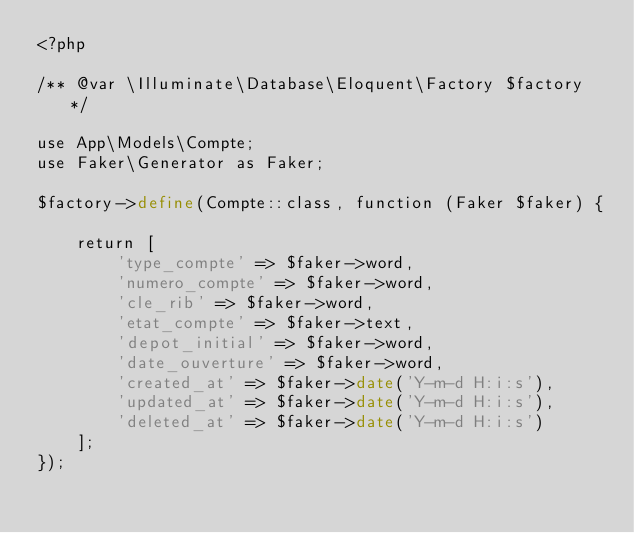Convert code to text. <code><loc_0><loc_0><loc_500><loc_500><_PHP_><?php

/** @var \Illuminate\Database\Eloquent\Factory $factory */

use App\Models\Compte;
use Faker\Generator as Faker;

$factory->define(Compte::class, function (Faker $faker) {

    return [
        'type_compte' => $faker->word,
        'numero_compte' => $faker->word,
        'cle_rib' => $faker->word,
        'etat_compte' => $faker->text,
        'depot_initial' => $faker->word,
        'date_ouverture' => $faker->word,
        'created_at' => $faker->date('Y-m-d H:i:s'),
        'updated_at' => $faker->date('Y-m-d H:i:s'),
        'deleted_at' => $faker->date('Y-m-d H:i:s')
    ];
});
</code> 